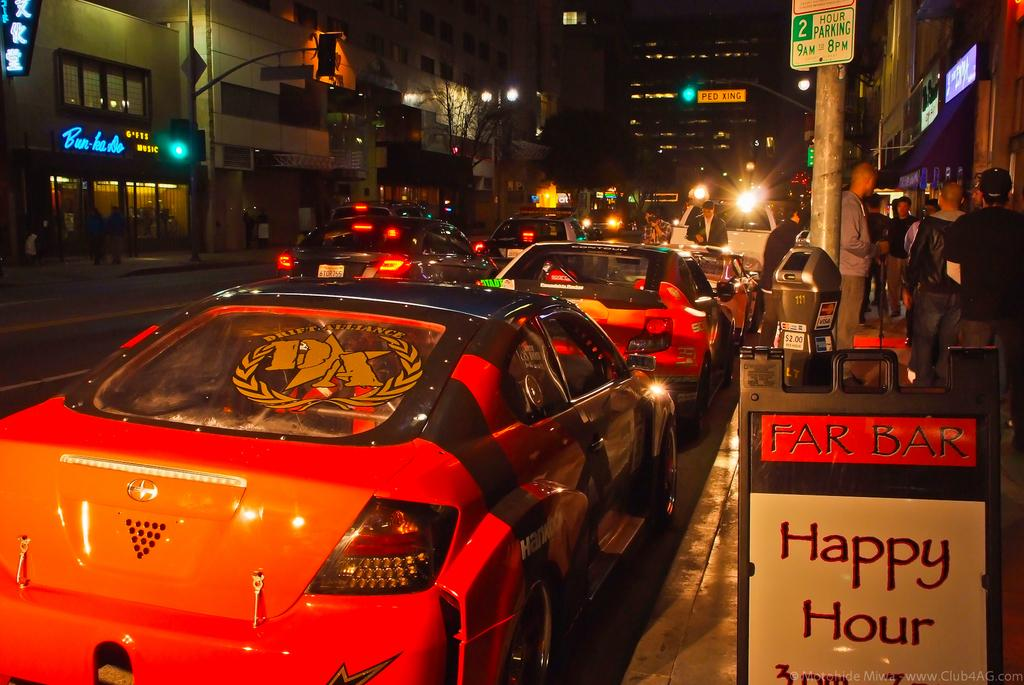What can be seen on the road in the image? There are many cars on the road in the image. What type of structures are visible in the image? There are buildings visible in the image. What else can be seen in the image besides cars and buildings? There are electrical poles in the image. How many babies are playing in the plot of land in the image? There is no plot of land or babies present in the image. 